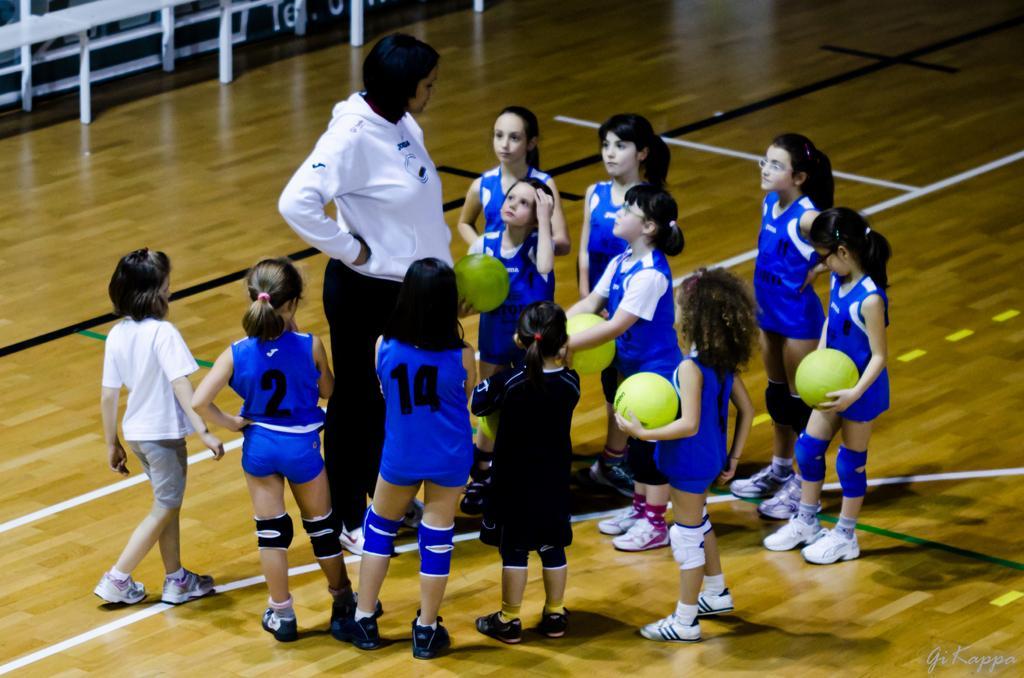Please provide a concise description of this image. In the picture we can see some girls are standing on the play floor and they are in blue color sports wear and holding green color balls and we can see one woman standing with them and she is with the white color dress and behind them we can see a railing which is white in color. 